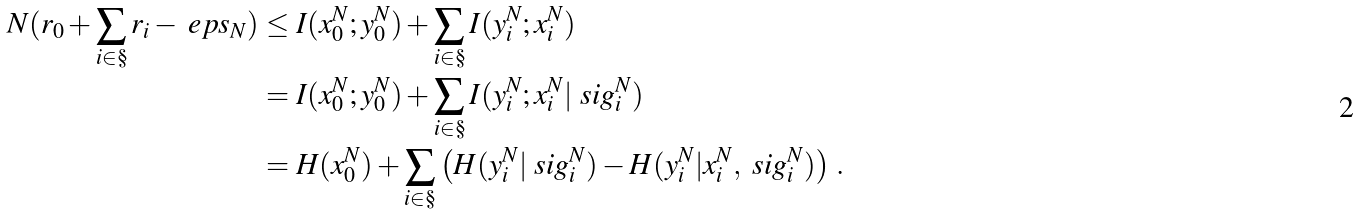Convert formula to latex. <formula><loc_0><loc_0><loc_500><loc_500>N ( r _ { 0 } + \sum _ { i \in \S } r _ { i } - \ e p s _ { N } ) & \leq I ( x _ { 0 } ^ { N } ; y _ { 0 } ^ { N } ) + \sum _ { i \in \S } I ( y _ { i } ^ { N } ; x _ { i } ^ { N } ) \\ & = I ( x _ { 0 } ^ { N } ; y _ { 0 } ^ { N } ) + \sum _ { i \in \S } I ( y _ { i } ^ { N } ; x _ { i } ^ { N } | \ s i g _ { i } ^ { N } ) \\ & = H ( x _ { 0 } ^ { N } ) + \sum _ { i \in \S } \left ( H ( y _ { i } ^ { N } | \ s i g _ { i } ^ { N } ) - H ( y _ { i } ^ { N } | x _ { i } ^ { N } , \ s i g _ { i } ^ { N } ) \right ) \, .</formula> 